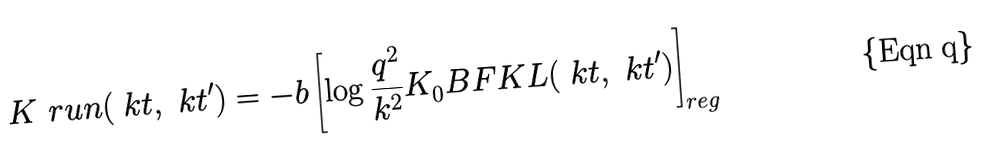Convert formula to latex. <formula><loc_0><loc_0><loc_500><loc_500>K ^ { \ } r u n ( \ k t , \ k t ^ { \prime } ) = - b \left [ \log \frac { q ^ { 2 } } { k ^ { 2 } } K _ { 0 } ^ { \ } B F K L ( \ k t , \ k t ^ { \prime } ) \right ] _ { r e g }</formula> 